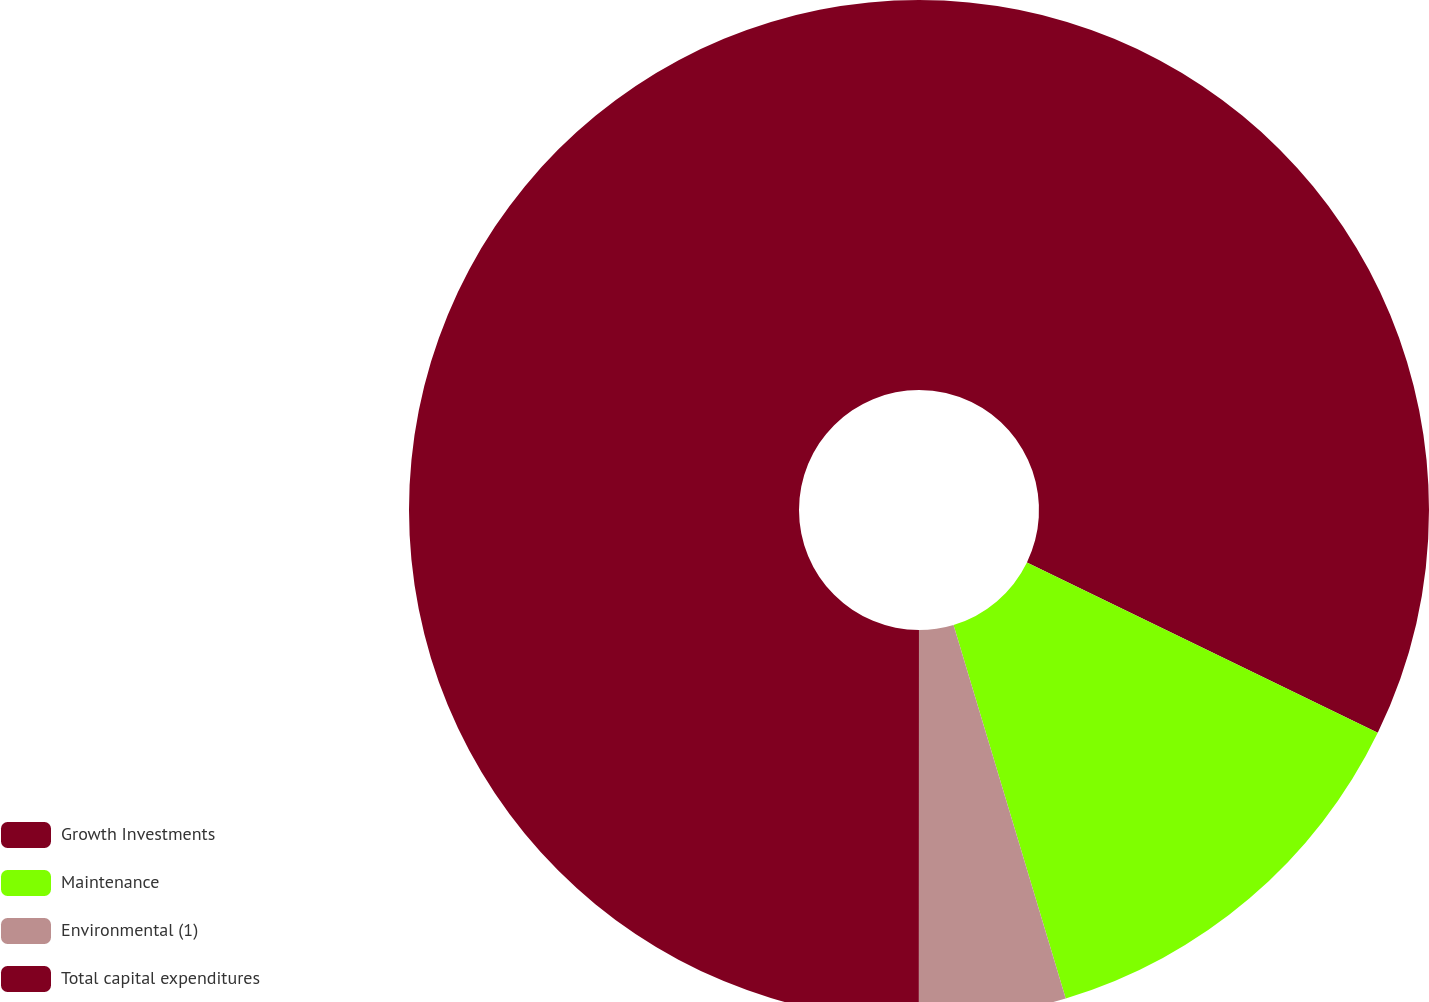<chart> <loc_0><loc_0><loc_500><loc_500><pie_chart><fcel>Growth Investments<fcel>Maintenance<fcel>Environmental (1)<fcel>Total capital expenditures<nl><fcel>32.2%<fcel>13.16%<fcel>4.65%<fcel>50.0%<nl></chart> 